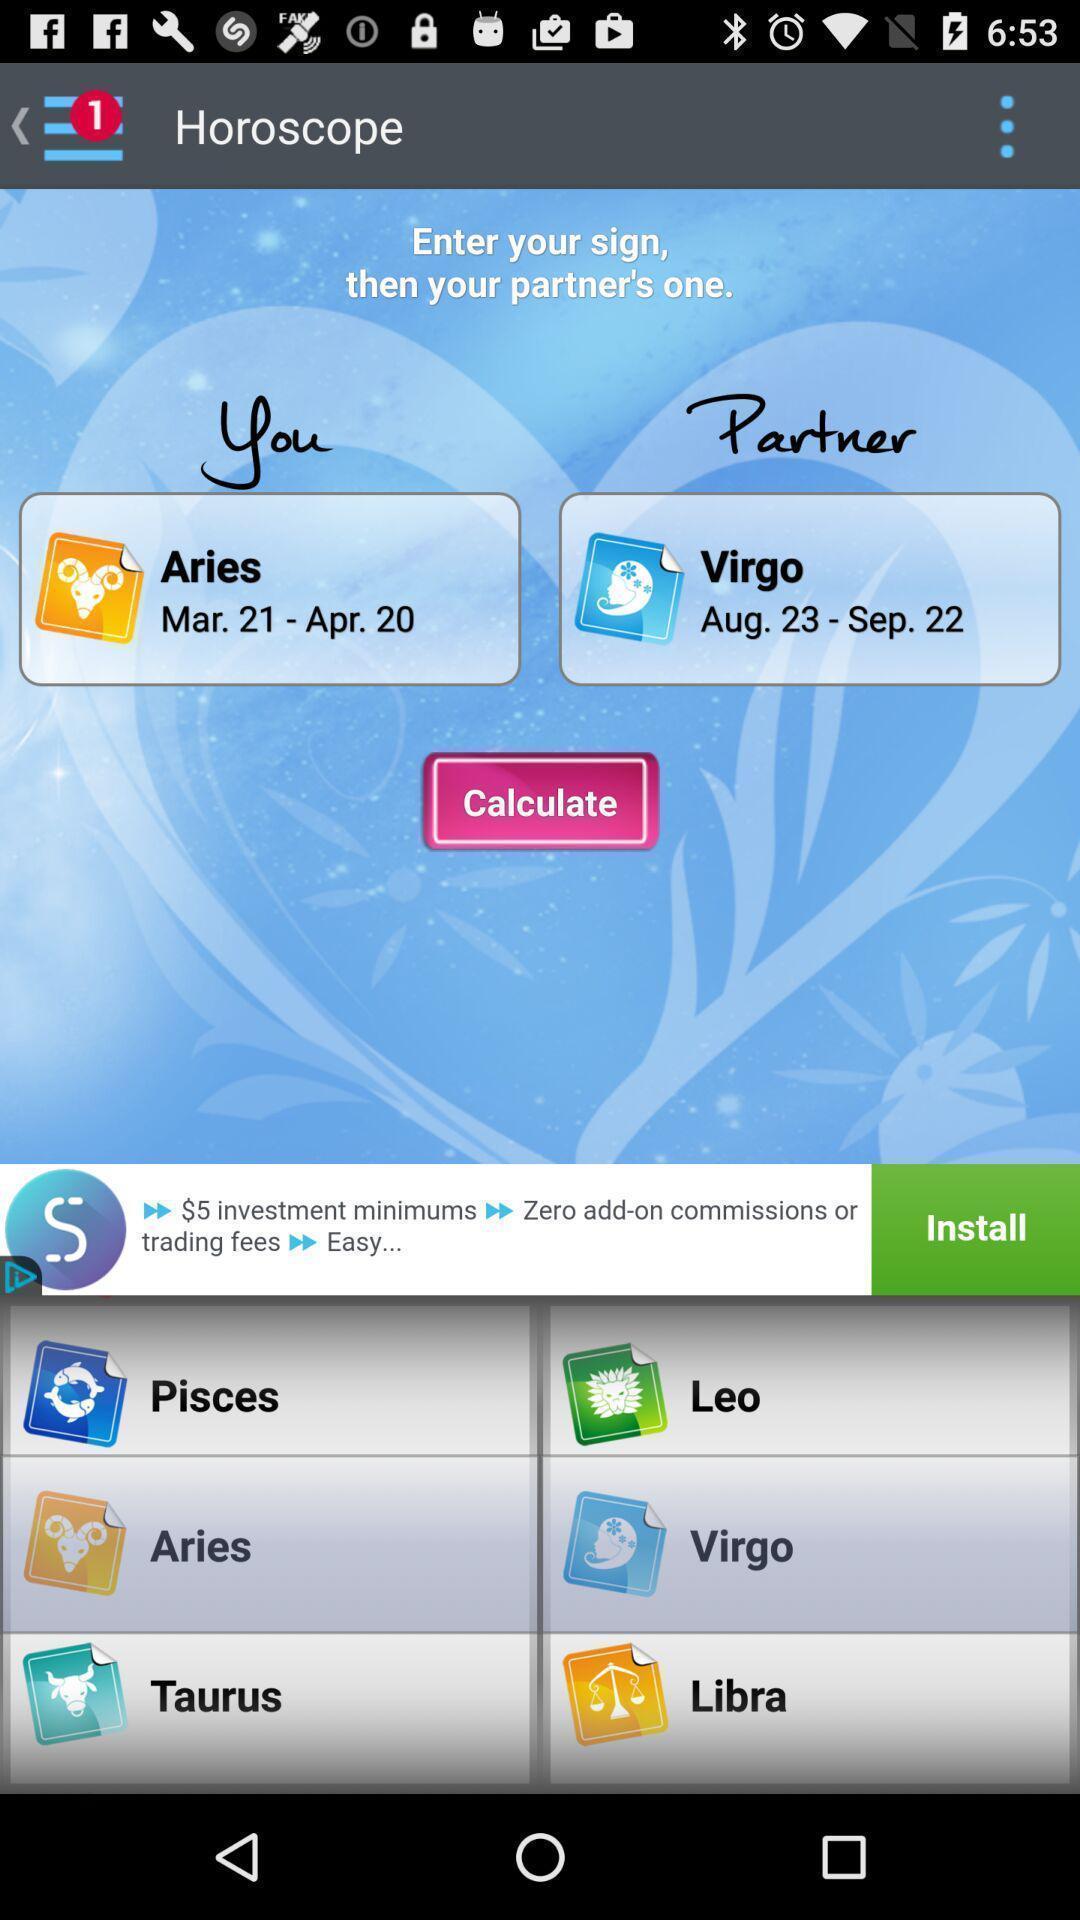What details can you identify in this image? Page showing information from a horoscope app. 